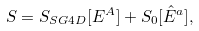<formula> <loc_0><loc_0><loc_500><loc_500>S = S _ { S G 4 D } [ E ^ { A } ] + S _ { 0 } [ \hat { E } ^ { a } ] ,</formula> 